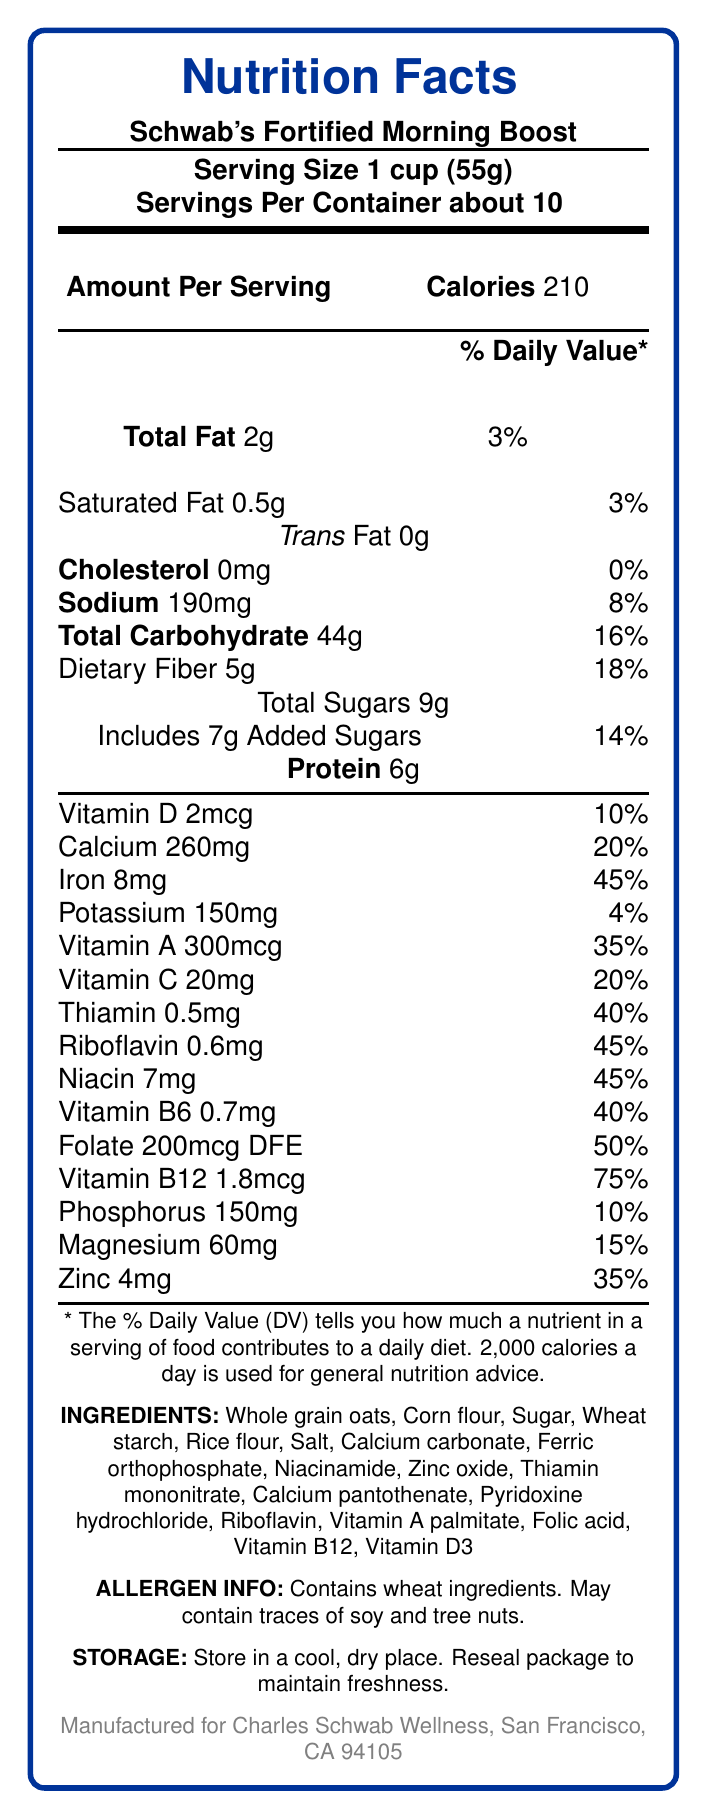what is the serving size of Schwab's Fortified Morning Boost? The document specifies that the serving size is 1 cup (55g).
Answer: 1 cup (55g) how many calories are there per serving? The document indicates that there are 210 calories per serving.
Answer: 210 what is the total fat content per serving? According to the document, the total fat content per serving is 2g.
Answer: 2g how much dietary fiber does one serving contain? The document states that each serving contains 5g of dietary fiber.
Answer: 5g what is the percentage of daily value for iron provided by one serving? The document mentions that one serving provides 45% of the daily value for iron.
Answer: 45% how many servings are there in one container? The document states that there are about 10 servings per container.
Answer: about 10 what are the main vitamins and minerals added to this cereal? A. Vitamin D, Calcium, Iron B. Thiamin, Vitamin C, Potassium C. Vitamin A, Vitamin B12, Magnesium The document lists Vitamin A, Vitamin B12, and Magnesium under the vitamins and minerals section.
Answer: C what percentage of the daily value of Vitamin B12 does one serving contain? A. 50% B. 40% C. 75% D. 35% The document shows that one serving contains 75% of the daily value for Vitamin B12.
Answer: C does this cereal contain any cholesterol? The document lists the cholesterol content as 0mg, indicating there is no cholesterol.
Answer: No is this cereal suitable for someone with a wheat allergy? The document states that the product contains wheat ingredients, making it unsuitable for someone with a wheat allergy.
Answer: No summarize the key nutritional components of Schwab's Fortified Morning Boost. The summary highlights the key nutritional components, serving size, and allergen information from the document.
Answer: Schwab's Fortified Morning Boost is a fortified breakfast cereal that contains 210 calories per serving, with added vitamins and minerals such as calcium, iron, vitamin D, vitamin A, and vitamin C. It has a serving size of 1 cup (55g) and provides about 10 servings per container. The cereal includes dietary fibers, sugars, proteins, and various micronutrients contributing to daily nutritional values. The product contains wheat ingredients and may have traces of soy and tree nuts. where was Schwab's Fortified Morning Boost manufactured? The document does not provide information on where the cereal was manufactured, only indicating that it was manufactured for Charles Schwab Wellness, San Francisco, CA 94105.
Answer: Cannot be determined 